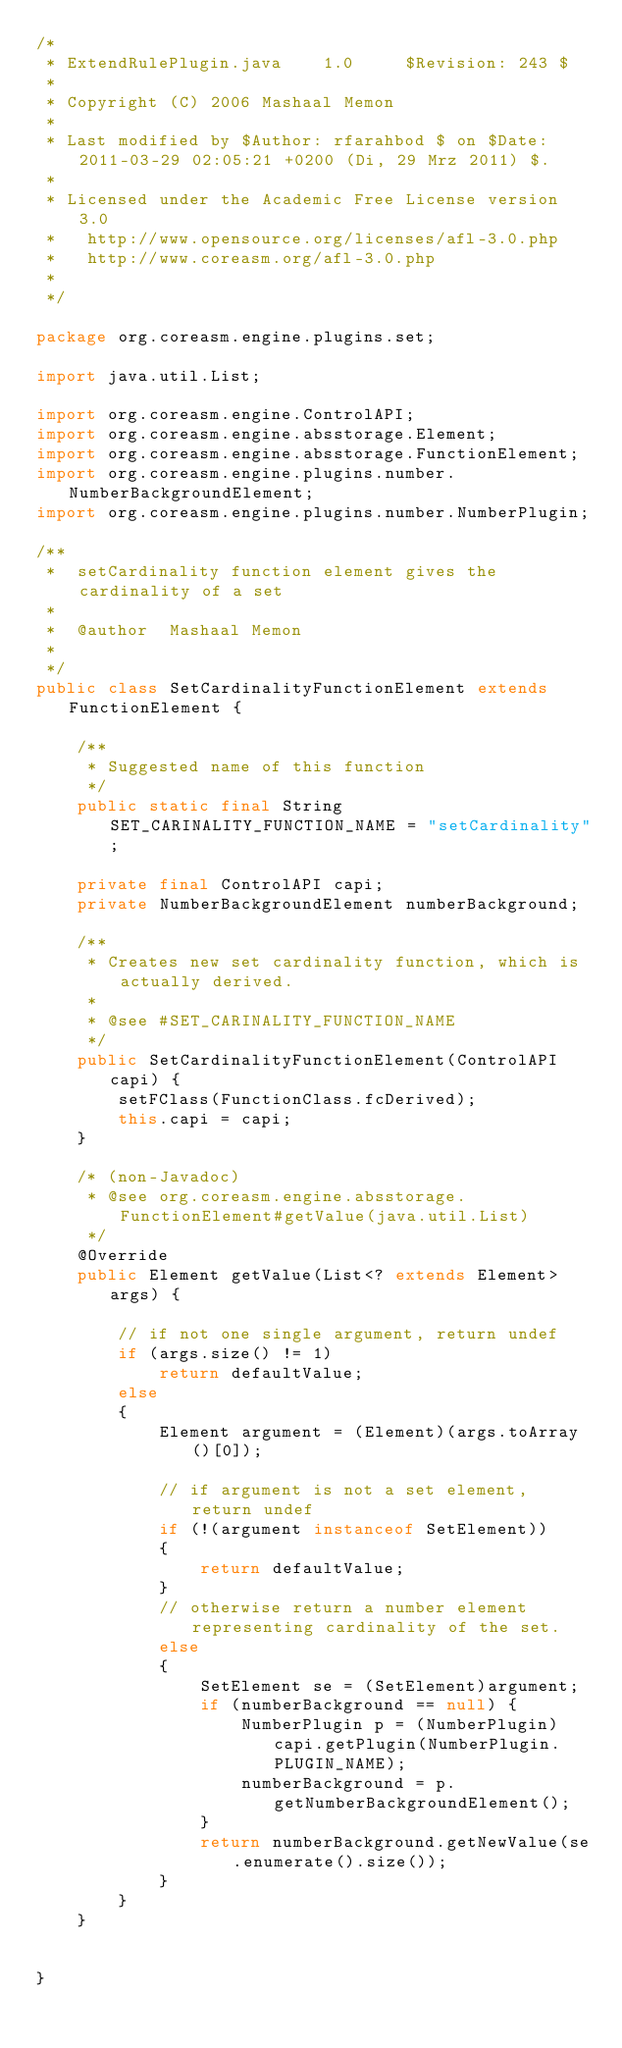<code> <loc_0><loc_0><loc_500><loc_500><_Java_>/*
 * ExtendRulePlugin.java    1.0     $Revision: 243 $
 *
 * Copyright (C) 2006 Mashaal Memon
 *
 * Last modified by $Author: rfarahbod $ on $Date: 2011-03-29 02:05:21 +0200 (Di, 29 Mrz 2011) $.
 *
 * Licensed under the Academic Free License version 3.0
 *   http://www.opensource.org/licenses/afl-3.0.php
 *   http://www.coreasm.org/afl-3.0.php
 *
 */

package org.coreasm.engine.plugins.set;

import java.util.List;

import org.coreasm.engine.ControlAPI;
import org.coreasm.engine.absstorage.Element;
import org.coreasm.engine.absstorage.FunctionElement;
import org.coreasm.engine.plugins.number.NumberBackgroundElement;
import org.coreasm.engine.plugins.number.NumberPlugin;

/**
 *	setCardinality function element gives the cardinality of a set
 *
 *  @author  Mashaal Memon
 *
 */
public class SetCardinalityFunctionElement extends FunctionElement {

	/**
	 * Suggested name of this function
	 */
	public static final String SET_CARINALITY_FUNCTION_NAME = "setCardinality";

	private final ControlAPI capi;
	private NumberBackgroundElement numberBackground;

	/**
	 * Creates new set cardinality function, which is actually derived.
	 *
	 * @see #SET_CARINALITY_FUNCTION_NAME
	 */
	public SetCardinalityFunctionElement(ControlAPI capi) {
		setFClass(FunctionClass.fcDerived);
		this.capi = capi;
	}

	/* (non-Javadoc)
	 * @see org.coreasm.engine.absstorage.FunctionElement#getValue(java.util.List)
	 */
	@Override
	public Element getValue(List<? extends Element> args) {

		// if not one single argument, return undef
		if (args.size() != 1)
			return defaultValue;
		else
		{
			Element argument = (Element)(args.toArray()[0]);

			// if argument is not a set element, return undef
			if (!(argument instanceof SetElement))
			{
				return defaultValue;
			}
			// otherwise return a number element representing cardinality of the set.
			else
			{
				SetElement se = (SetElement)argument;
				if (numberBackground == null) {
					NumberPlugin p = (NumberPlugin)capi.getPlugin(NumberPlugin.PLUGIN_NAME);
					numberBackground = p.getNumberBackgroundElement();
				}
				return numberBackground.getNewValue(se.enumerate().size());
			}
		}
	}


}
</code> 